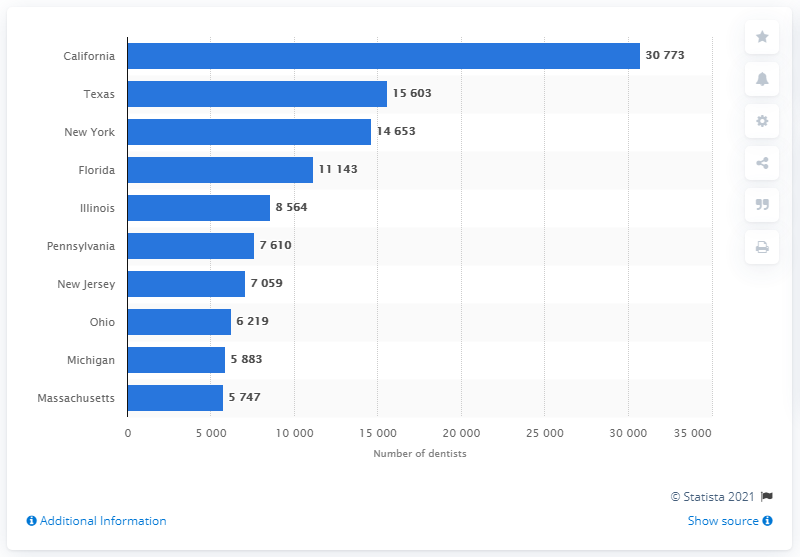Give some essential details in this illustration. According to data from 2019, Texas had the highest number of dentists among the states of New York, California, and Texas. 